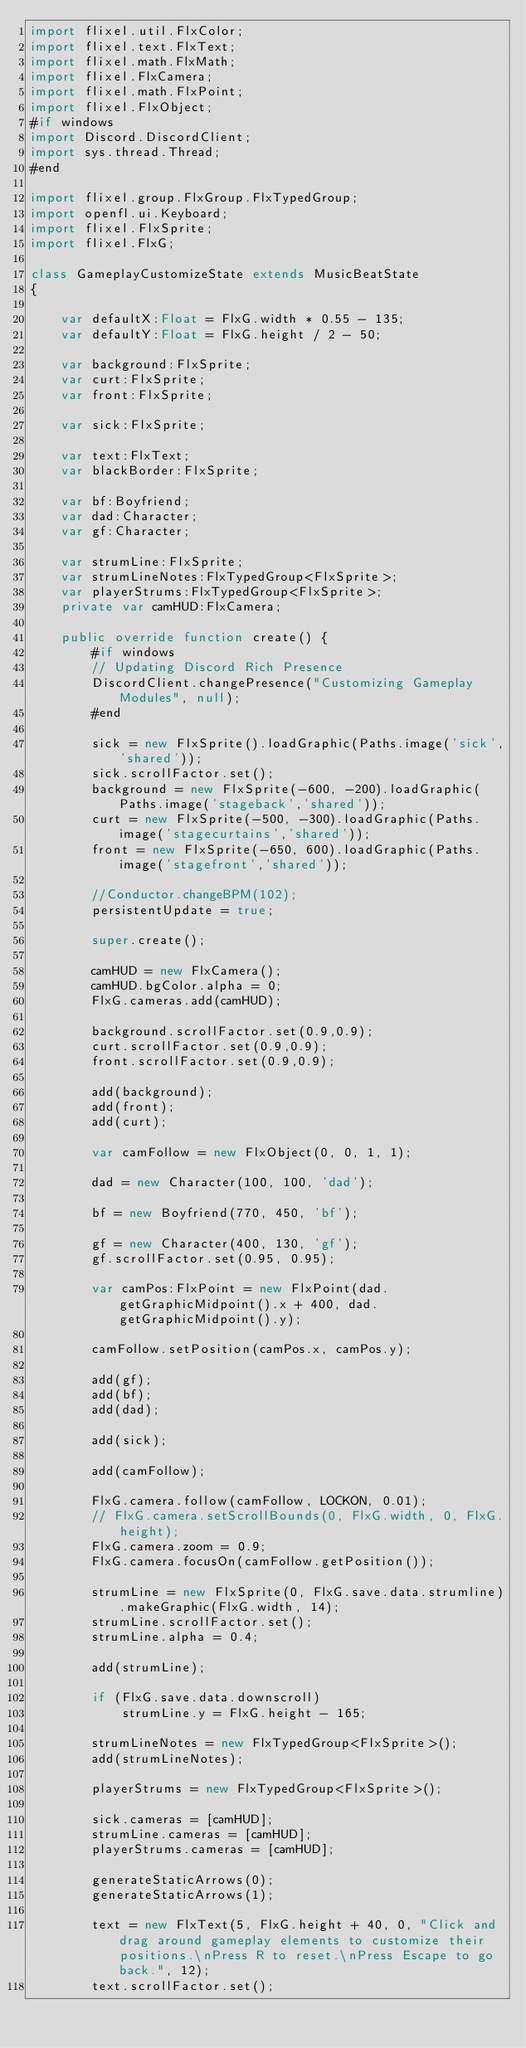<code> <loc_0><loc_0><loc_500><loc_500><_Haxe_>import flixel.util.FlxColor;
import flixel.text.FlxText;
import flixel.math.FlxMath;
import flixel.FlxCamera;
import flixel.math.FlxPoint;
import flixel.FlxObject;
#if windows
import Discord.DiscordClient;
import sys.thread.Thread;
#end

import flixel.group.FlxGroup.FlxTypedGroup;
import openfl.ui.Keyboard;
import flixel.FlxSprite;
import flixel.FlxG;

class GameplayCustomizeState extends MusicBeatState
{

    var defaultX:Float = FlxG.width * 0.55 - 135;
    var defaultY:Float = FlxG.height / 2 - 50;

    var background:FlxSprite;
    var curt:FlxSprite;
    var front:FlxSprite;

    var sick:FlxSprite;

    var text:FlxText;
    var blackBorder:FlxSprite;

    var bf:Boyfriend;
    var dad:Character;
    var gf:Character;

    var strumLine:FlxSprite;
    var strumLineNotes:FlxTypedGroup<FlxSprite>;
    var playerStrums:FlxTypedGroup<FlxSprite>;
    private var camHUD:FlxCamera;
    
    public override function create() {
        #if windows
		// Updating Discord Rich Presence
		DiscordClient.changePresence("Customizing Gameplay Modules", null);
		#end

        sick = new FlxSprite().loadGraphic(Paths.image('sick','shared'));
        sick.scrollFactor.set();
        background = new FlxSprite(-600, -200).loadGraphic(Paths.image('stageback','shared'));
        curt = new FlxSprite(-500, -300).loadGraphic(Paths.image('stagecurtains','shared'));
        front = new FlxSprite(-650, 600).loadGraphic(Paths.image('stagefront','shared'));

		//Conductor.changeBPM(102);
		persistentUpdate = true;

        super.create();

		camHUD = new FlxCamera();
		camHUD.bgColor.alpha = 0;
        FlxG.cameras.add(camHUD);

        background.scrollFactor.set(0.9,0.9);
        curt.scrollFactor.set(0.9,0.9);
        front.scrollFactor.set(0.9,0.9);

        add(background);
        add(front);
        add(curt);

		var camFollow = new FlxObject(0, 0, 1, 1);

		dad = new Character(100, 100, 'dad');

        bf = new Boyfriend(770, 450, 'bf');

        gf = new Character(400, 130, 'gf');
		gf.scrollFactor.set(0.95, 0.95);

		var camPos:FlxPoint = new FlxPoint(dad.getGraphicMidpoint().x + 400, dad.getGraphicMidpoint().y);

		camFollow.setPosition(camPos.x, camPos.y);

        add(gf);
        add(bf);
        add(dad);

        add(sick);

		add(camFollow);

		FlxG.camera.follow(camFollow, LOCKON, 0.01);
		// FlxG.camera.setScrollBounds(0, FlxG.width, 0, FlxG.height);
		FlxG.camera.zoom = 0.9;
		FlxG.camera.focusOn(camFollow.getPosition());

		strumLine = new FlxSprite(0, FlxG.save.data.strumline).makeGraphic(FlxG.width, 14);
		strumLine.scrollFactor.set();
        strumLine.alpha = 0.4;

        add(strumLine);
		
		if (FlxG.save.data.downscroll)
			strumLine.y = FlxG.height - 165;

		strumLineNotes = new FlxTypedGroup<FlxSprite>();
		add(strumLineNotes);

		playerStrums = new FlxTypedGroup<FlxSprite>();

        sick.cameras = [camHUD];
        strumLine.cameras = [camHUD];
        playerStrums.cameras = [camHUD];
        
		generateStaticArrows(0);
		generateStaticArrows(1);

        text = new FlxText(5, FlxG.height + 40, 0, "Click and drag around gameplay elements to customize their positions.\nPress R to reset.\nPress Escape to go back.", 12);
		text.scrollFactor.set();</code> 